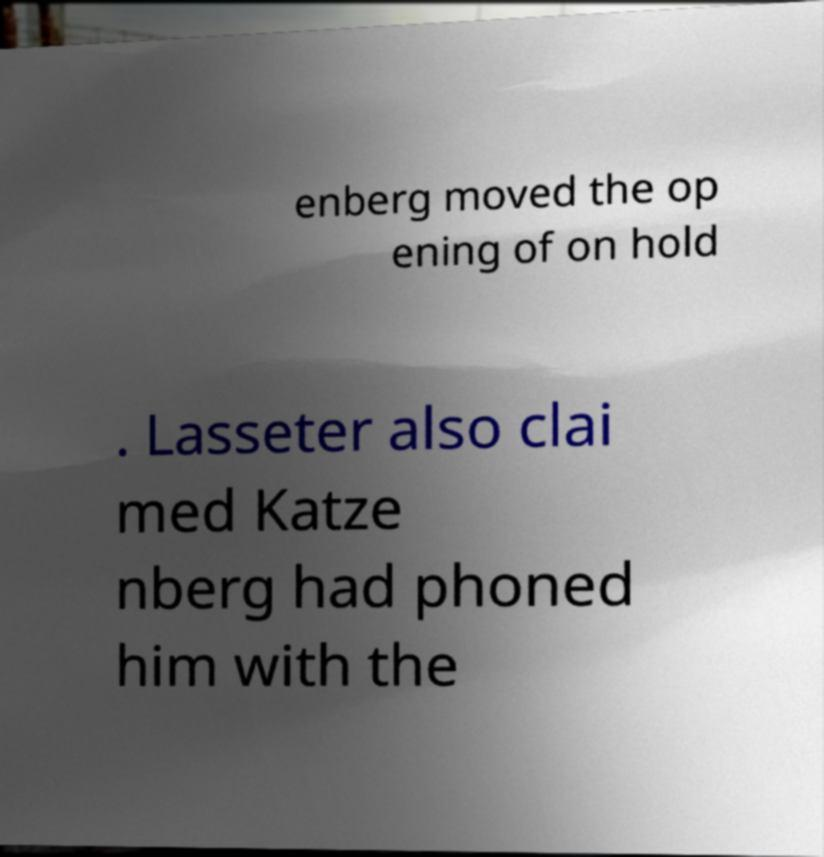Could you assist in decoding the text presented in this image and type it out clearly? enberg moved the op ening of on hold . Lasseter also clai med Katze nberg had phoned him with the 